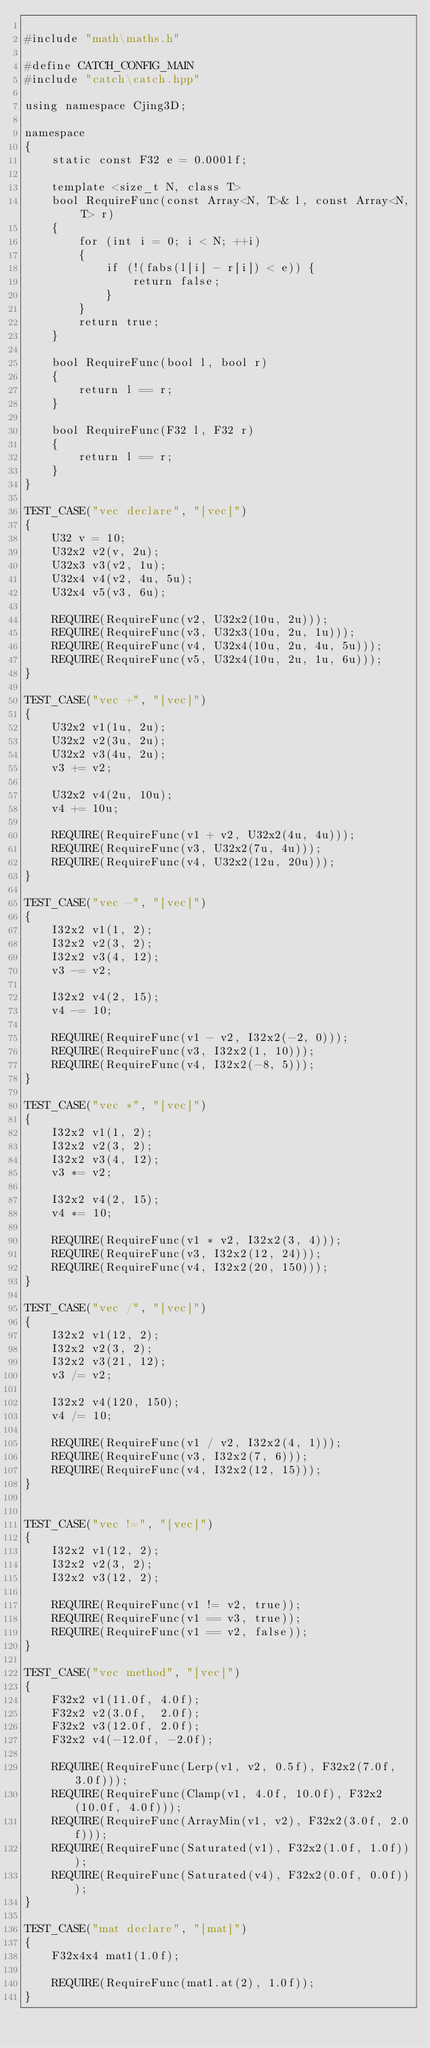<code> <loc_0><loc_0><loc_500><loc_500><_C++_>
#include "math\maths.h"

#define CATCH_CONFIG_MAIN
#include "catch\catch.hpp"

using namespace Cjing3D;

namespace
{
    static const F32 e = 0.0001f;

    template <size_t N, class T>
    bool RequireFunc(const Array<N, T>& l, const Array<N, T> r)
    {
        for (int i = 0; i < N; ++i)
        {
            if (!(fabs(l[i] - r[i]) < e)) {
                return false;
            }
        }
        return true;
    }

    bool RequireFunc(bool l, bool r)
    {
        return l == r;
    }

    bool RequireFunc(F32 l, F32 r)
    {
        return l == r;
    }
}

TEST_CASE("vec declare", "[vec]")
{
	U32 v = 10;
	U32x2 v2(v, 2u);
    U32x3 v3(v2, 1u);
    U32x4 v4(v2, 4u, 5u);
    U32x4 v5(v3, 6u);

    REQUIRE(RequireFunc(v2, U32x2(10u, 2u)));
    REQUIRE(RequireFunc(v3, U32x3(10u, 2u, 1u)));
    REQUIRE(RequireFunc(v4, U32x4(10u, 2u, 4u, 5u)));
    REQUIRE(RequireFunc(v5, U32x4(10u, 2u, 1u, 6u)));
}

TEST_CASE("vec +", "[vec]")
{
    U32x2 v1(1u, 2u);
    U32x2 v2(3u, 2u);
    U32x2 v3(4u, 2u);
    v3 += v2;

    U32x2 v4(2u, 10u);
    v4 += 10u;

    REQUIRE(RequireFunc(v1 + v2, U32x2(4u, 4u)));
    REQUIRE(RequireFunc(v3, U32x2(7u, 4u)));
    REQUIRE(RequireFunc(v4, U32x2(12u, 20u)));
}

TEST_CASE("vec -", "[vec]")
{
    I32x2 v1(1, 2);
    I32x2 v2(3, 2);
    I32x2 v3(4, 12);
    v3 -= v2;

    I32x2 v4(2, 15);
    v4 -= 10;

    REQUIRE(RequireFunc(v1 - v2, I32x2(-2, 0)));
    REQUIRE(RequireFunc(v3, I32x2(1, 10)));
    REQUIRE(RequireFunc(v4, I32x2(-8, 5)));
}

TEST_CASE("vec *", "[vec]")
{
    I32x2 v1(1, 2);
    I32x2 v2(3, 2);
    I32x2 v3(4, 12);
    v3 *= v2;

    I32x2 v4(2, 15);
    v4 *= 10;

    REQUIRE(RequireFunc(v1 * v2, I32x2(3, 4)));
    REQUIRE(RequireFunc(v3, I32x2(12, 24)));
    REQUIRE(RequireFunc(v4, I32x2(20, 150)));
}

TEST_CASE("vec /", "[vec]")
{
    I32x2 v1(12, 2);
    I32x2 v2(3, 2);
    I32x2 v3(21, 12);
    v3 /= v2;

    I32x2 v4(120, 150);
    v4 /= 10;

    REQUIRE(RequireFunc(v1 / v2, I32x2(4, 1)));
    REQUIRE(RequireFunc(v3, I32x2(7, 6)));
    REQUIRE(RequireFunc(v4, I32x2(12, 15)));
}


TEST_CASE("vec !=", "[vec]")
{
    I32x2 v1(12, 2);
    I32x2 v2(3, 2);
    I32x2 v3(12, 2);

    REQUIRE(RequireFunc(v1 != v2, true));
    REQUIRE(RequireFunc(v1 == v3, true));
    REQUIRE(RequireFunc(v1 == v2, false));
}

TEST_CASE("vec method", "[vec]")
{
    F32x2 v1(11.0f, 4.0f);
    F32x2 v2(3.0f,  2.0f);
    F32x2 v3(12.0f, 2.0f);
    F32x2 v4(-12.0f, -2.0f);

    REQUIRE(RequireFunc(Lerp(v1, v2, 0.5f), F32x2(7.0f, 3.0f)));
    REQUIRE(RequireFunc(Clamp(v1, 4.0f, 10.0f), F32x2(10.0f, 4.0f)));
    REQUIRE(RequireFunc(ArrayMin(v1, v2), F32x2(3.0f, 2.0f)));
    REQUIRE(RequireFunc(Saturated(v1), F32x2(1.0f, 1.0f)));
    REQUIRE(RequireFunc(Saturated(v4), F32x2(0.0f, 0.0f)));
}

TEST_CASE("mat declare", "[mat]")
{
    F32x4x4 mat1(1.0f);

    REQUIRE(RequireFunc(mat1.at(2), 1.0f));
}
</code> 